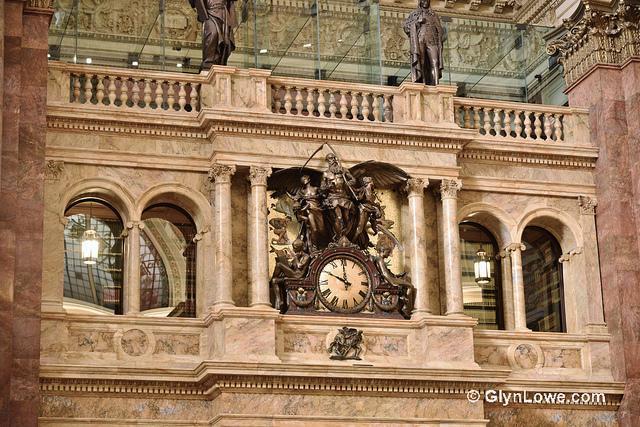How many arches are in the building?
Give a very brief answer. 4. How many people are swimming?
Give a very brief answer. 0. 